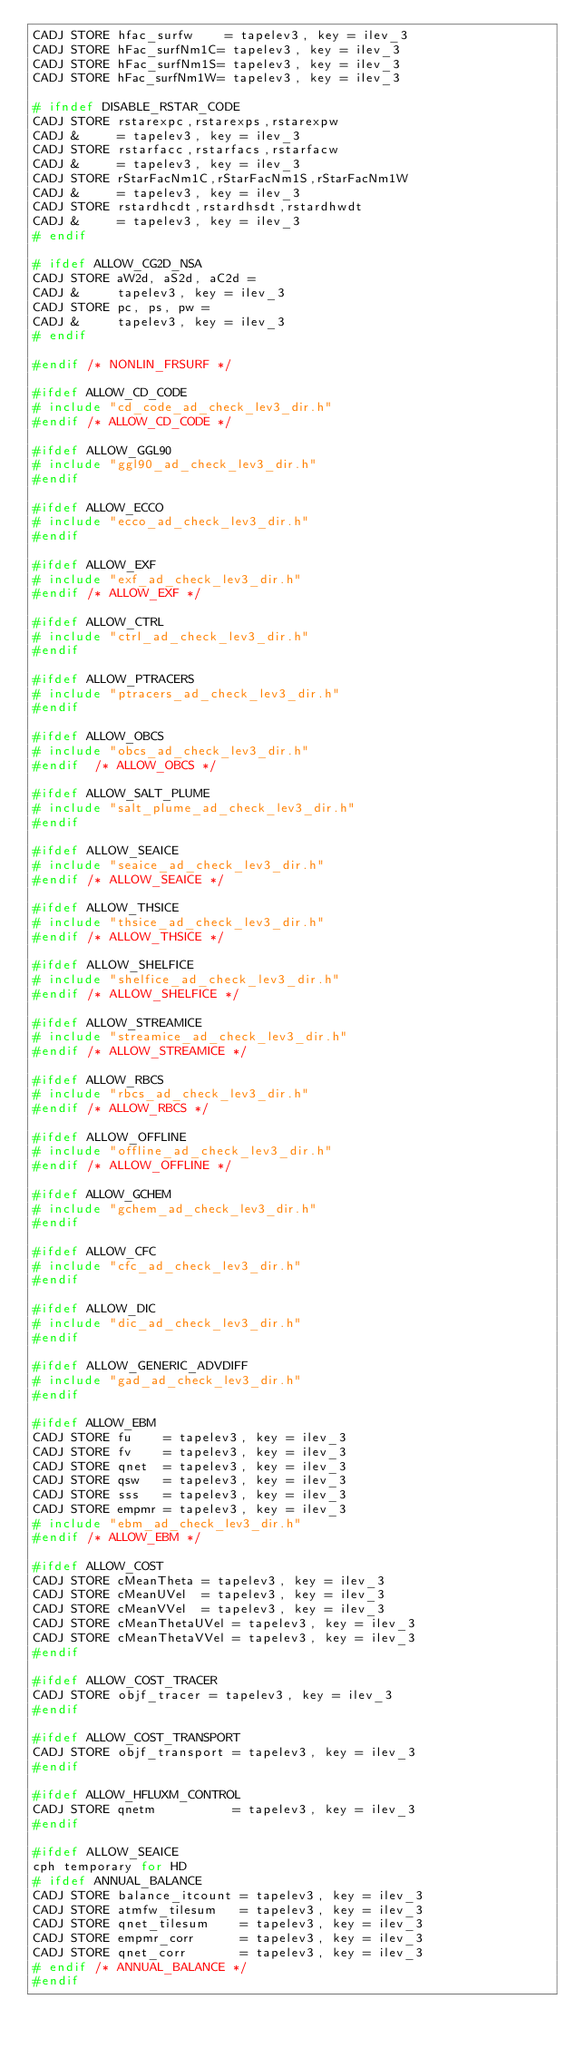Convert code to text. <code><loc_0><loc_0><loc_500><loc_500><_C_>CADJ STORE hfac_surfw    = tapelev3, key = ilev_3
CADJ STORE hFac_surfNm1C= tapelev3, key = ilev_3
CADJ STORE hFac_surfNm1S= tapelev3, key = ilev_3
CADJ STORE hFac_surfNm1W= tapelev3, key = ilev_3

# ifndef DISABLE_RSTAR_CODE
CADJ STORE rstarexpc,rstarexps,rstarexpw 
CADJ &     = tapelev3, key = ilev_3
CADJ STORE rstarfacc,rstarfacs,rstarfacw 
CADJ &     = tapelev3, key = ilev_3
CADJ STORE rStarFacNm1C,rStarFacNm1S,rStarFacNm1W
CADJ &     = tapelev3, key = ilev_3
CADJ STORE rstardhcdt,rstardhsdt,rstardhwdt 
CADJ &     = tapelev3, key = ilev_3
# endif

# ifdef ALLOW_CG2D_NSA
CADJ STORE aW2d, aS2d, aC2d =
CADJ &     tapelev3, key = ilev_3
CADJ STORE pc, ps, pw =
CADJ &     tapelev3, key = ilev_3
# endif

#endif /* NONLIN_FRSURF */

#ifdef ALLOW_CD_CODE
# include "cd_code_ad_check_lev3_dir.h"
#endif /* ALLOW_CD_CODE */

#ifdef ALLOW_GGL90
# include "ggl90_ad_check_lev3_dir.h"
#endif

#ifdef ALLOW_ECCO
# include "ecco_ad_check_lev3_dir.h"
#endif

#ifdef ALLOW_EXF
# include "exf_ad_check_lev3_dir.h"
#endif /* ALLOW_EXF */

#ifdef ALLOW_CTRL
# include "ctrl_ad_check_lev3_dir.h"
#endif 

#ifdef ALLOW_PTRACERS
# include "ptracers_ad_check_lev3_dir.h"
#endif

#ifdef ALLOW_OBCS
# include "obcs_ad_check_lev3_dir.h"
#endif  /* ALLOW_OBCS */

#ifdef ALLOW_SALT_PLUME
# include "salt_plume_ad_check_lev3_dir.h"
#endif

#ifdef ALLOW_SEAICE
# include "seaice_ad_check_lev3_dir.h"
#endif /* ALLOW_SEAICE */

#ifdef ALLOW_THSICE
# include "thsice_ad_check_lev3_dir.h"
#endif /* ALLOW_THSICE */

#ifdef ALLOW_SHELFICE
# include "shelfice_ad_check_lev3_dir.h"
#endif /* ALLOW_SHELFICE */

#ifdef ALLOW_STREAMICE
# include "streamice_ad_check_lev3_dir.h"
#endif /* ALLOW_STREAMICE */

#ifdef ALLOW_RBCS
# include "rbcs_ad_check_lev3_dir.h"
#endif /* ALLOW_RBCS */

#ifdef ALLOW_OFFLINE
# include "offline_ad_check_lev3_dir.h"
#endif /* ALLOW_OFFLINE */

#ifdef ALLOW_GCHEM
# include "gchem_ad_check_lev3_dir.h"
#endif
 
#ifdef ALLOW_CFC
# include "cfc_ad_check_lev3_dir.h"
#endif
 
#ifdef ALLOW_DIC
# include "dic_ad_check_lev3_dir.h"
#endif

#ifdef ALLOW_GENERIC_ADVDIFF
# include "gad_ad_check_lev3_dir.h"
#endif

#ifdef ALLOW_EBM
CADJ STORE fu    = tapelev3, key = ilev_3
CADJ STORE fv    = tapelev3, key = ilev_3
CADJ STORE qnet  = tapelev3, key = ilev_3
CADJ STORE qsw   = tapelev3, key = ilev_3
CADJ STORE sss   = tapelev3, key = ilev_3
CADJ STORE empmr = tapelev3, key = ilev_3
# include "ebm_ad_check_lev3_dir.h"
#endif /* ALLOW_EBM */

#ifdef ALLOW_COST
CADJ STORE cMeanTheta = tapelev3, key = ilev_3
CADJ STORE cMeanUVel  = tapelev3, key = ilev_3
CADJ STORE cMeanVVel  = tapelev3, key = ilev_3
CADJ STORE cMeanThetaUVel = tapelev3, key = ilev_3
CADJ STORE cMeanThetaVVel = tapelev3, key = ilev_3
#endif

#ifdef ALLOW_COST_TRACER
CADJ STORE objf_tracer = tapelev3, key = ilev_3
#endif

#ifdef ALLOW_COST_TRANSPORT
CADJ STORE objf_transport = tapelev3, key = ilev_3
#endif

#ifdef ALLOW_HFLUXM_CONTROL
CADJ STORE qnetm          = tapelev3, key = ilev_3
#endif

#ifdef ALLOW_SEAICE
cph temporary for HD
# ifdef ANNUAL_BALANCE
CADJ STORE balance_itcount = tapelev3, key = ilev_3
CADJ STORE atmfw_tilesum   = tapelev3, key = ilev_3
CADJ STORE qnet_tilesum    = tapelev3, key = ilev_3
CADJ STORE empmr_corr      = tapelev3, key = ilev_3
CADJ STORE qnet_corr       = tapelev3, key = ilev_3
# endif /* ANNUAL_BALANCE */
#endif
</code> 